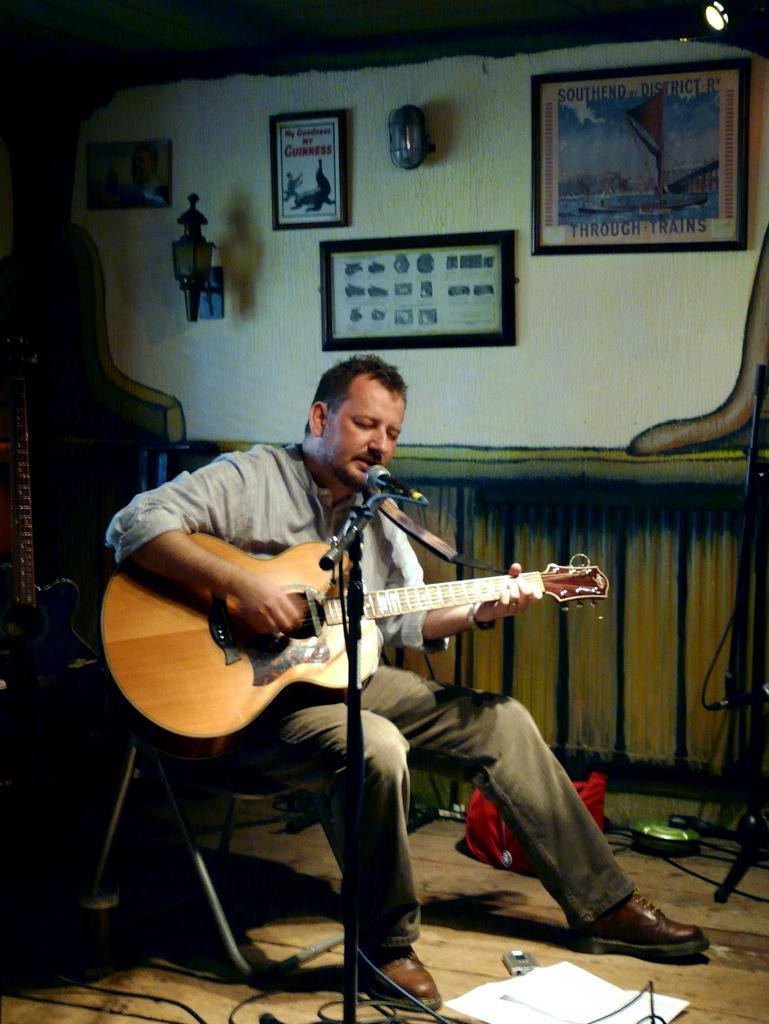Please provide a concise description of this image. This image has a man sitting on the chair holding a guitar and playing it. There is a mike stand before him. There are few picture frames attached to the wall and two lamps are also attaches to the wall. There is a paper on the floor and red colour cloth. 